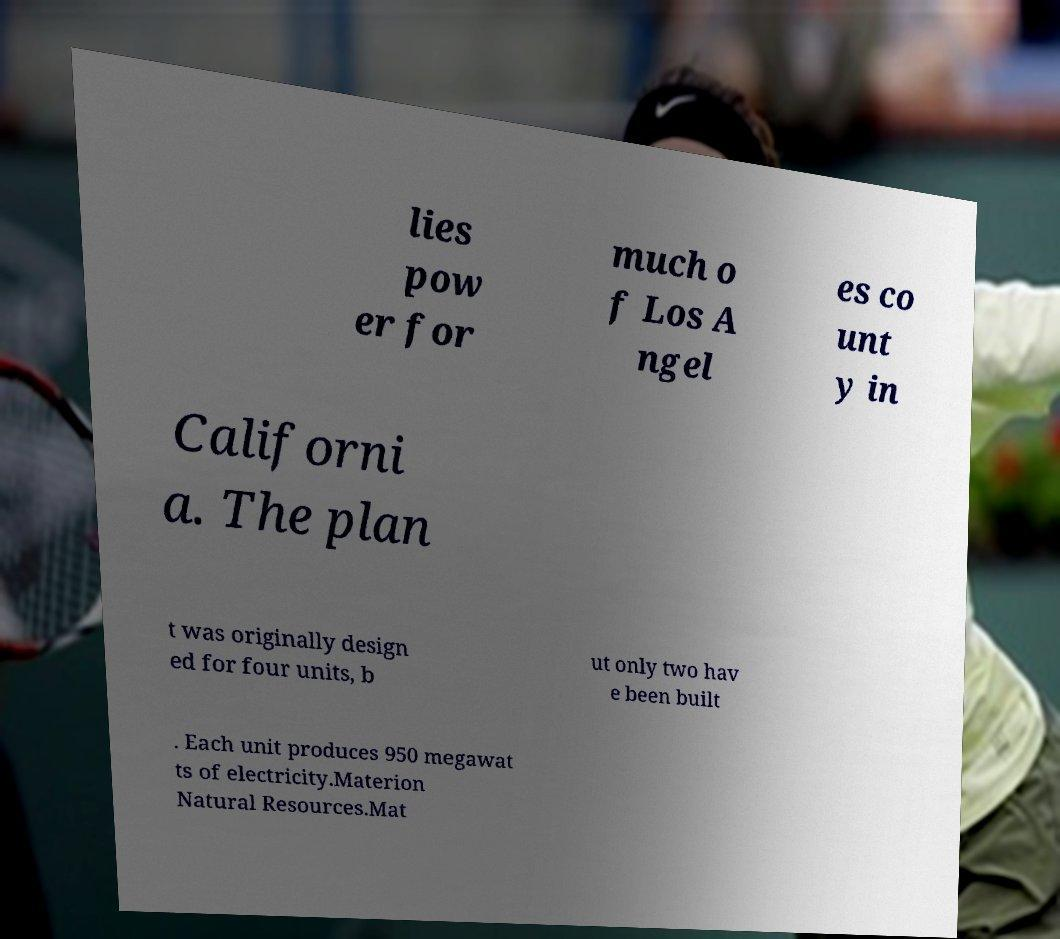Can you accurately transcribe the text from the provided image for me? lies pow er for much o f Los A ngel es co unt y in Californi a. The plan t was originally design ed for four units, b ut only two hav e been built . Each unit produces 950 megawat ts of electricity.Materion Natural Resources.Mat 